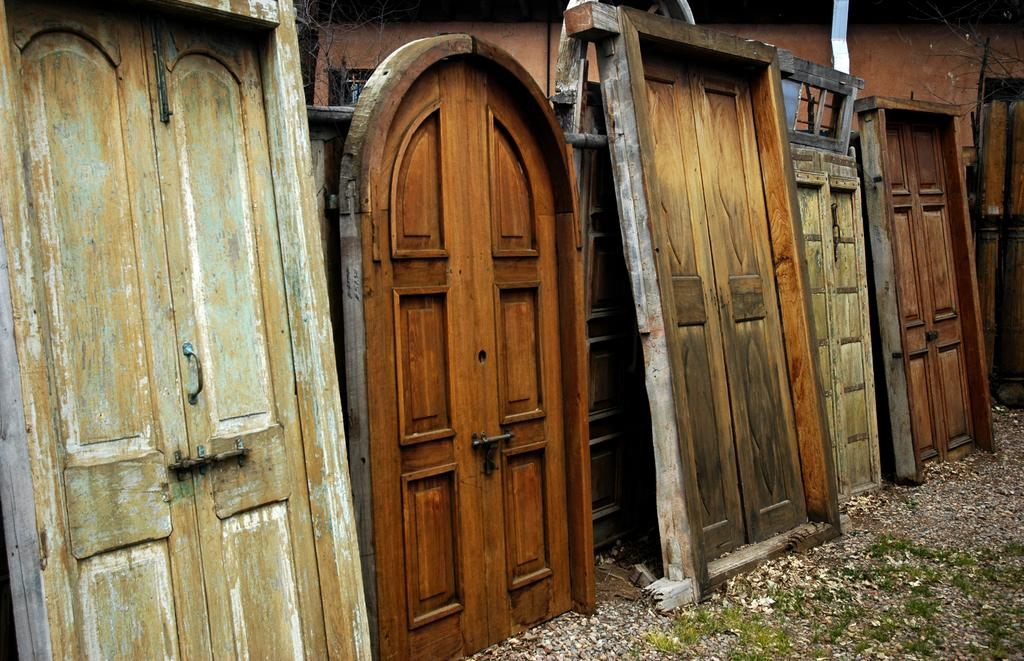What type of architectural feature can be seen in the image? There are doors in the image. What type of natural environment is visible in the image? There is grass in the bottom right corner of the image. What is visible in the background of the image? There is a wall and branches visible in the background of the image. What type of pencil can be seen in the image? There is no pencil present in the image. Are there any curtains visible in the image? There is no mention of curtains in the provided facts, and therefore we cannot determine if any are present in the image. --- Facts: 1. There is a person in the image. 2. The person is wearing a hat. 3. The person is holding a book. 4. There is a tree in the background of the image. 5. The sky is visible in the image. Absurd Topics: bicycle, parrot, ocean Conversation: What is the main subject of the image? The main subject of the image is a person. What is the person wearing in the image? The person is wearing a hat. What is the person holding in the image? The person is holding a book. What type of natural environment is visible in the background of the image? There is a tree in the background of the image. What is visible in the sky in the image? The sky is visible in the image. Reasoning: Let's think step by step in order to produce the conversation. We start by identifying the main subject in the image, which is the person. Then, we expand the conversation to include other items that are also visible, such as the hat, the book, the tree, and the sky. Each question is designed to elicit a specific detail about the image that is known from the provided facts. Absurd Question/Answer: Can you see any bicycles or parrots in the image? There is no mention of bicycles or parrots in the provided facts, and therefore we cannot determine if any are present in the image. Is the person standing near the ocean in the image? There is no mention of the ocean in the provided facts, and therefore we cannot determine if the person is near the ocean in the image. 